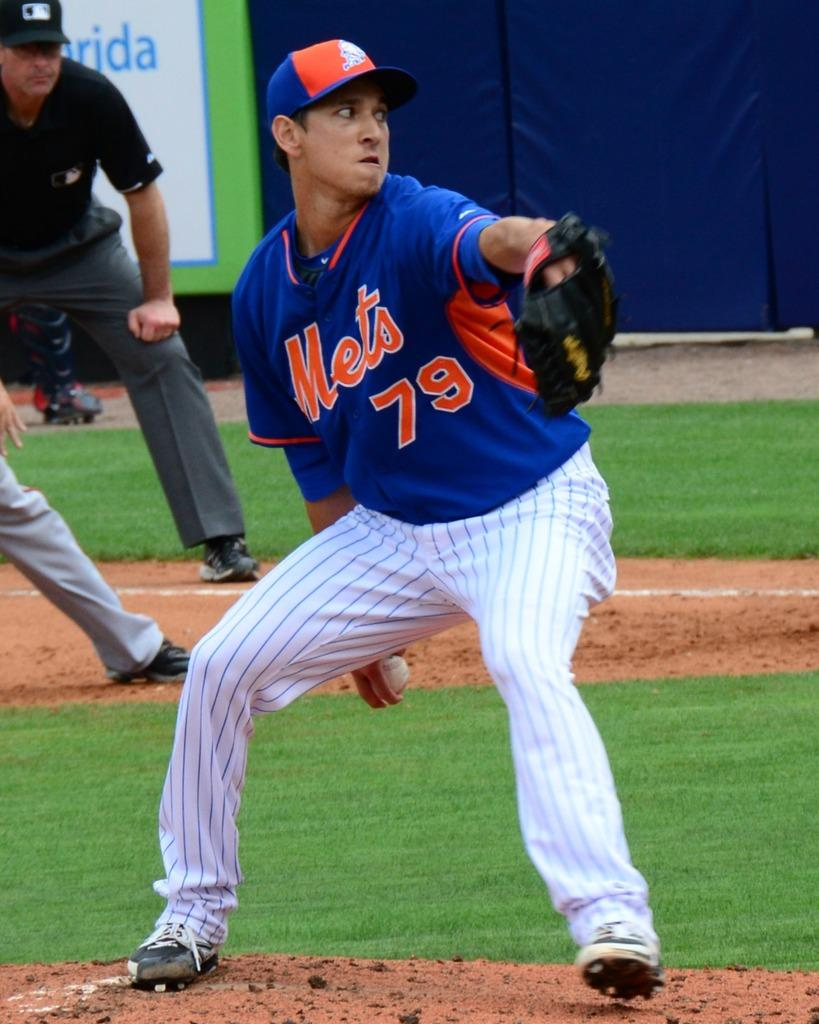<image>
Share a concise interpretation of the image provided. Mets baseball playing pitching a baseball in the outfield 